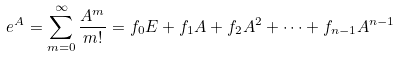Convert formula to latex. <formula><loc_0><loc_0><loc_500><loc_500>e ^ { A } = \sum _ { m = 0 } ^ { \infty } \frac { A ^ { m } } { m ! } = f _ { 0 } E + f _ { 1 } A + f _ { 2 } A ^ { 2 } + \cdots + f _ { n - 1 } A ^ { n - 1 }</formula> 